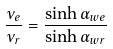<formula> <loc_0><loc_0><loc_500><loc_500>\frac { \nu _ { e } } { \nu _ { r } } = \frac { \sinh \alpha _ { w e } } { \sinh \alpha _ { w r } }</formula> 